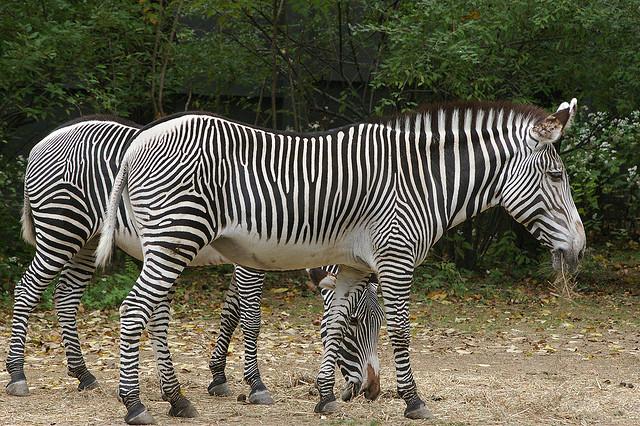How many lines do the zebras have?
Write a very short answer. 102. What is the design on zebras?
Be succinct. Stripes. How many zebras are there?
Quick response, please. 2. How many zebras are eating?
Answer briefly. 2. Is one of the zebras eating?
Answer briefly. Yes. 